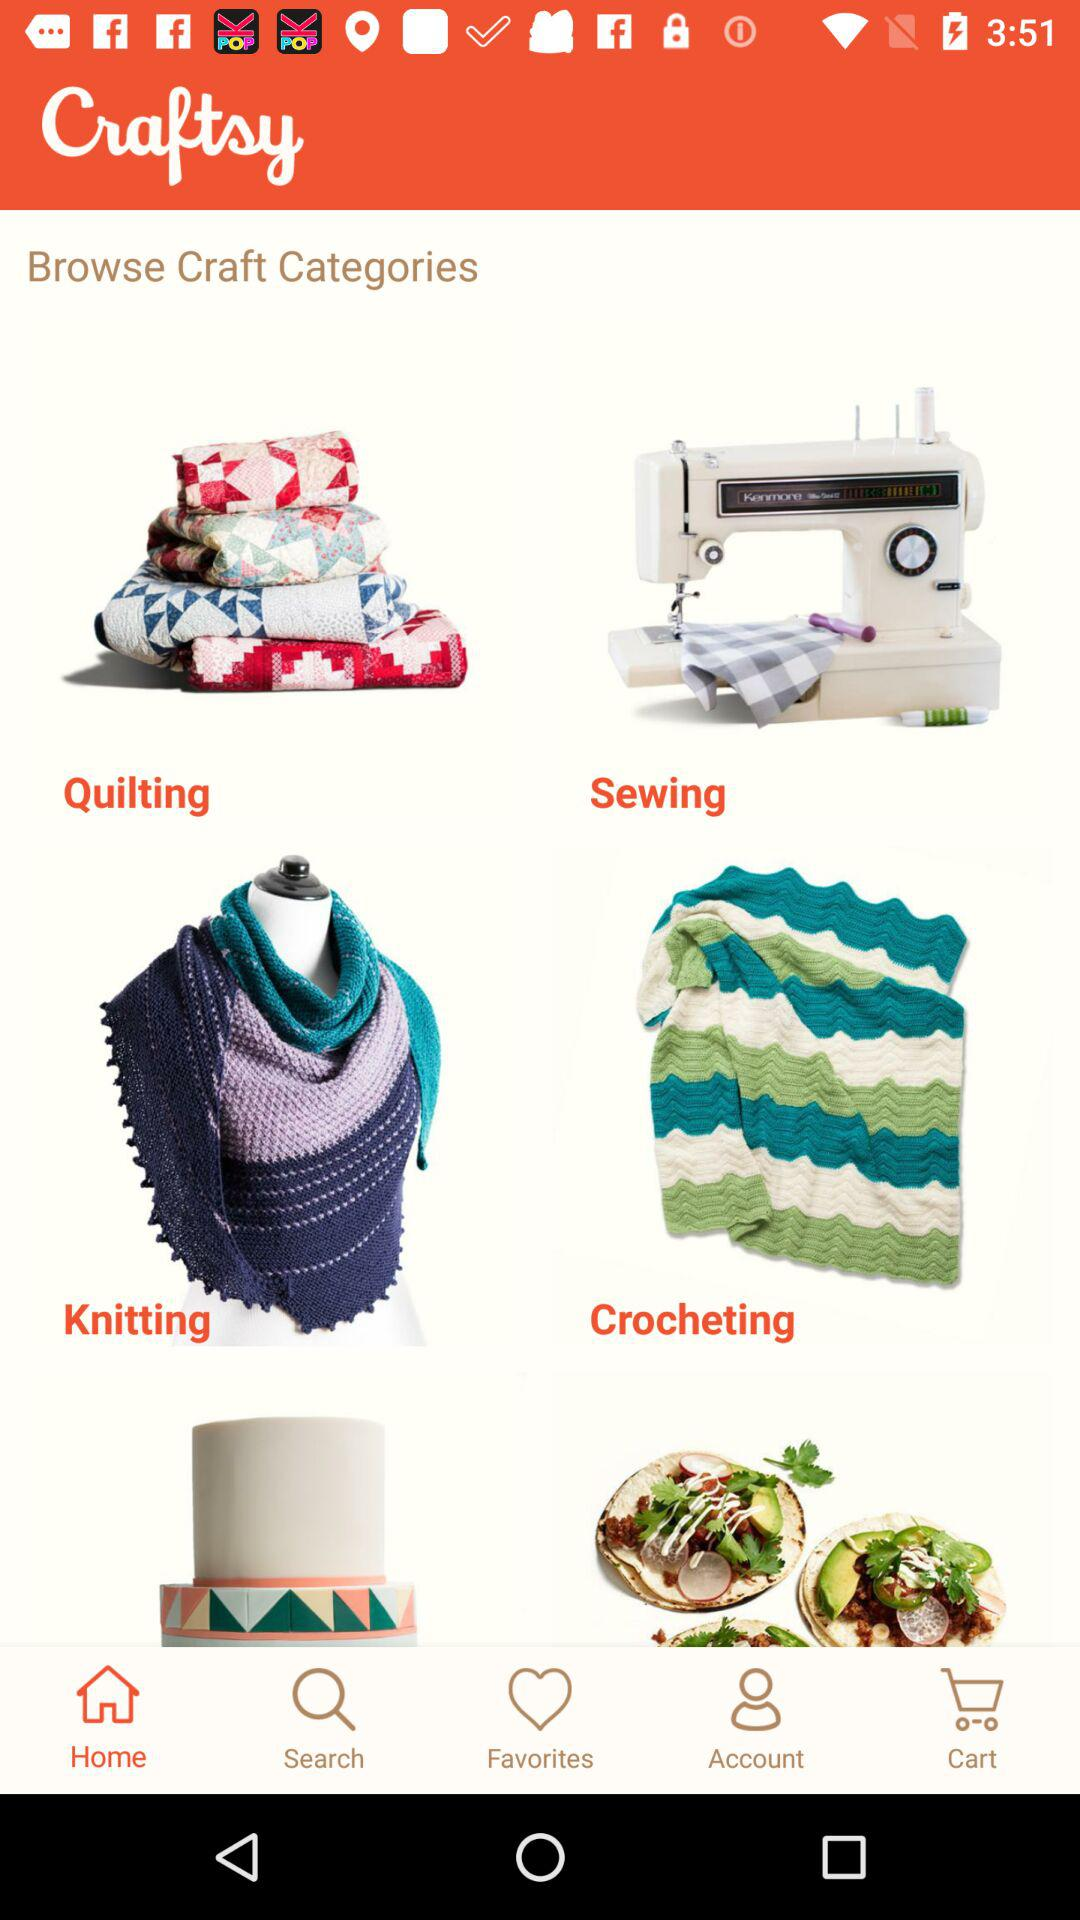Which craft categories are displayed? The displayed craft categories are "Quilting", "Sewing", "Knitting" and "Crocheting". 